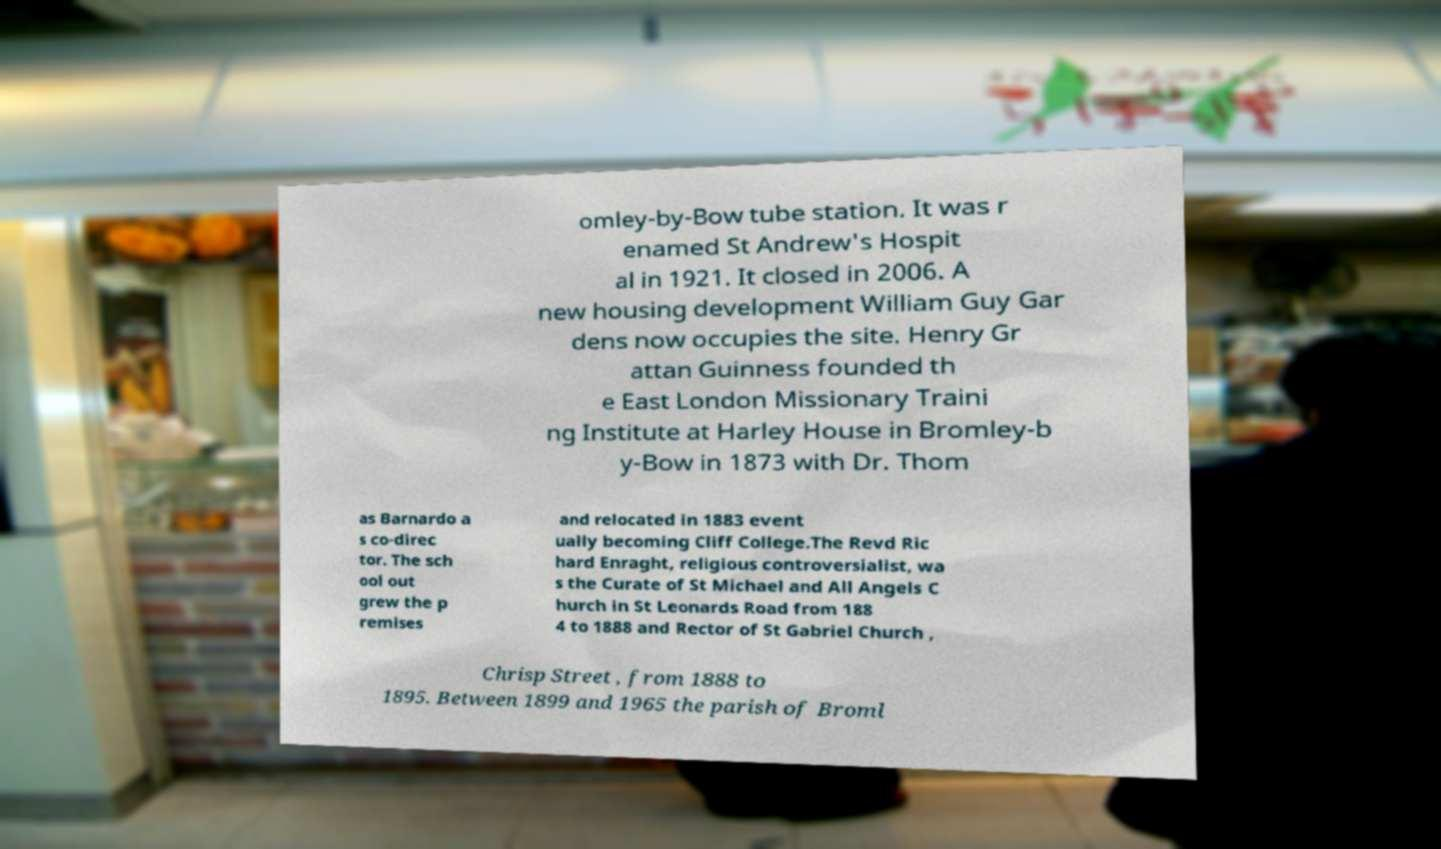I need the written content from this picture converted into text. Can you do that? omley-by-Bow tube station. It was r enamed St Andrew's Hospit al in 1921. It closed in 2006. A new housing development William Guy Gar dens now occupies the site. Henry Gr attan Guinness founded th e East London Missionary Traini ng Institute at Harley House in Bromley-b y-Bow in 1873 with Dr. Thom as Barnardo a s co-direc tor. The sch ool out grew the p remises and relocated in 1883 event ually becoming Cliff College.The Revd Ric hard Enraght, religious controversialist, wa s the Curate of St Michael and All Angels C hurch in St Leonards Road from 188 4 to 1888 and Rector of St Gabriel Church , Chrisp Street , from 1888 to 1895. Between 1899 and 1965 the parish of Broml 